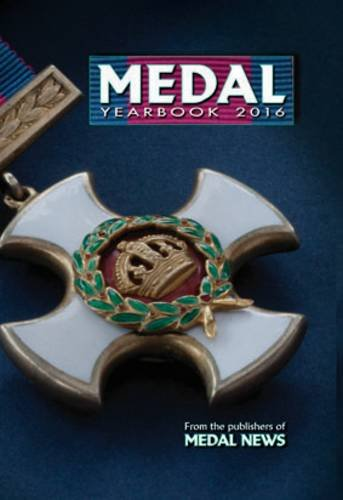What is the title of this book? The title of the book is 'Medal Yearbook 2016'. It is a specialized publication focusing on medals. 